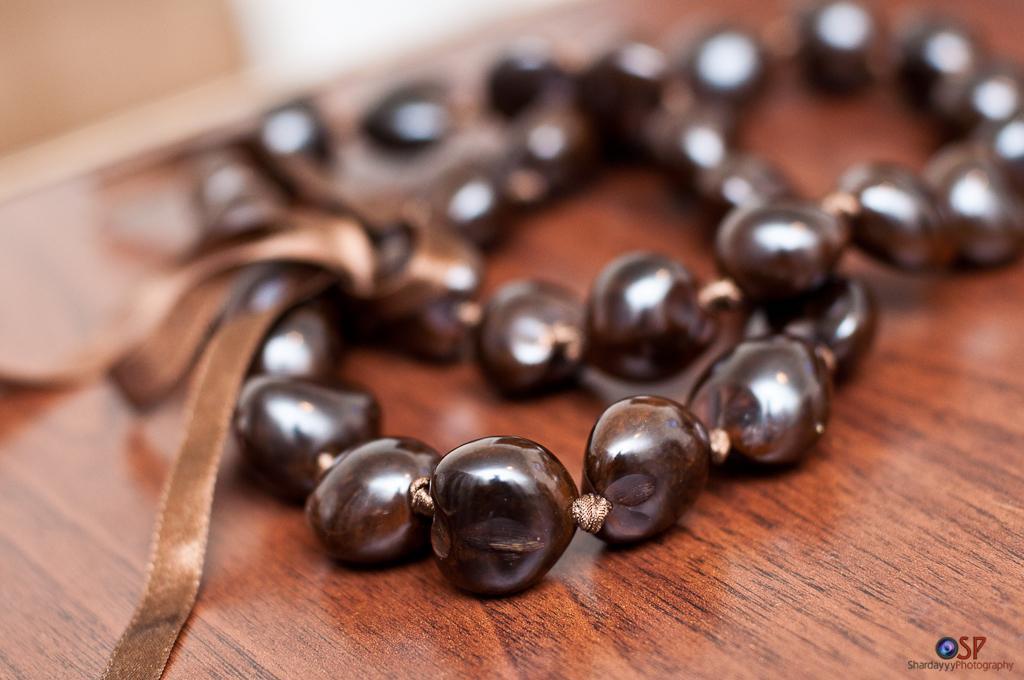Describe this image in one or two sentences. Here we can see beads chain on a wooden platform and there is a watermark. 